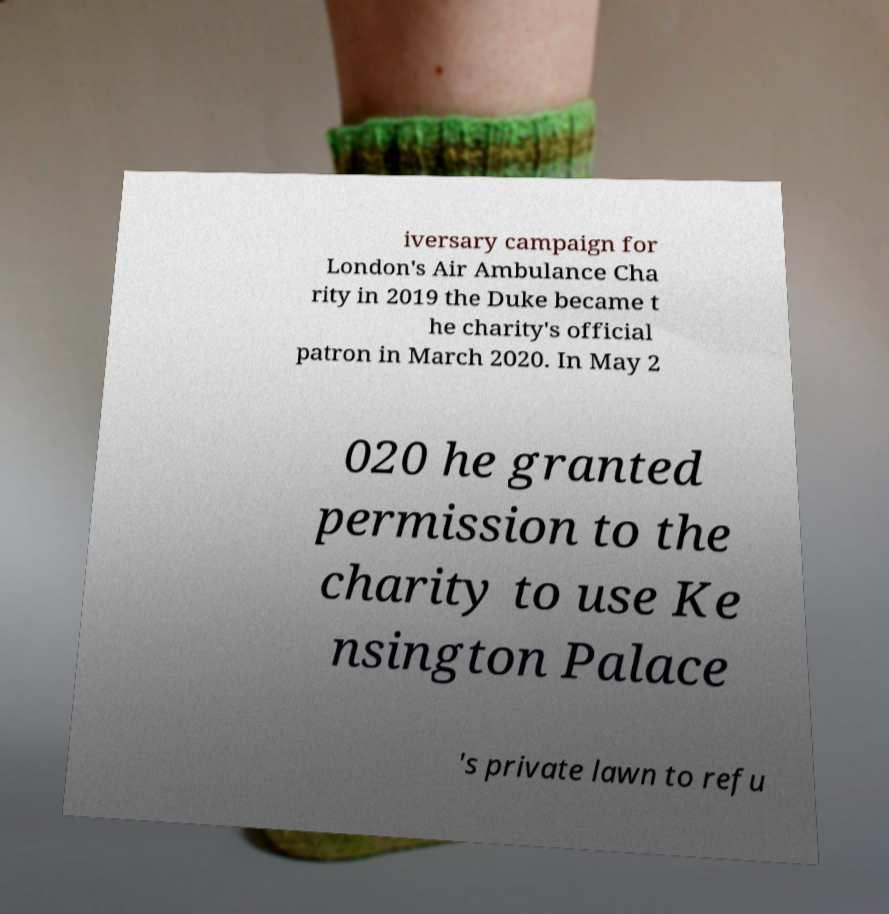Could you extract and type out the text from this image? iversary campaign for London's Air Ambulance Cha rity in 2019 the Duke became t he charity's official patron in March 2020. In May 2 020 he granted permission to the charity to use Ke nsington Palace 's private lawn to refu 